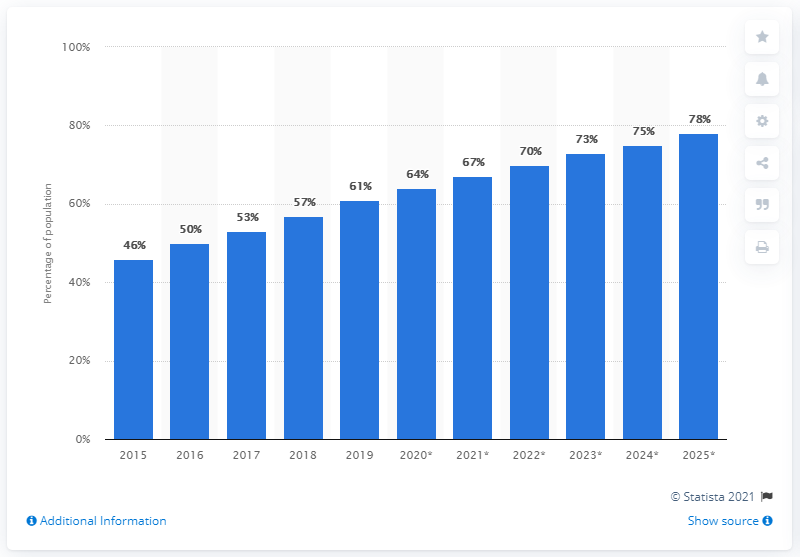Give some essential details in this illustration. In 2019, 61% of China's population accessed the internet from their mobile devices. 